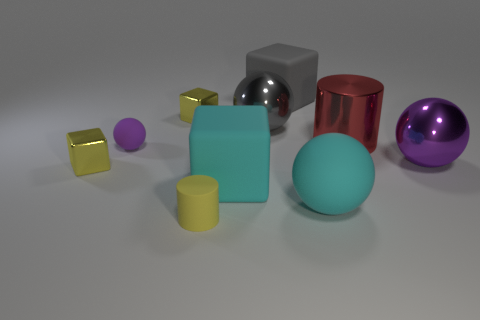Subtract all purple metallic balls. How many balls are left? 3 Subtract all yellow cylinders. How many cylinders are left? 1 Subtract all cylinders. How many objects are left? 8 Subtract 3 cubes. How many cubes are left? 1 Add 5 large shiny objects. How many large shiny objects are left? 8 Add 8 big gray matte spheres. How many big gray matte spheres exist? 8 Subtract 0 green balls. How many objects are left? 10 Subtract all purple cylinders. Subtract all purple blocks. How many cylinders are left? 2 Subtract all purple spheres. How many yellow blocks are left? 2 Subtract all large gray metal balls. Subtract all large matte balls. How many objects are left? 8 